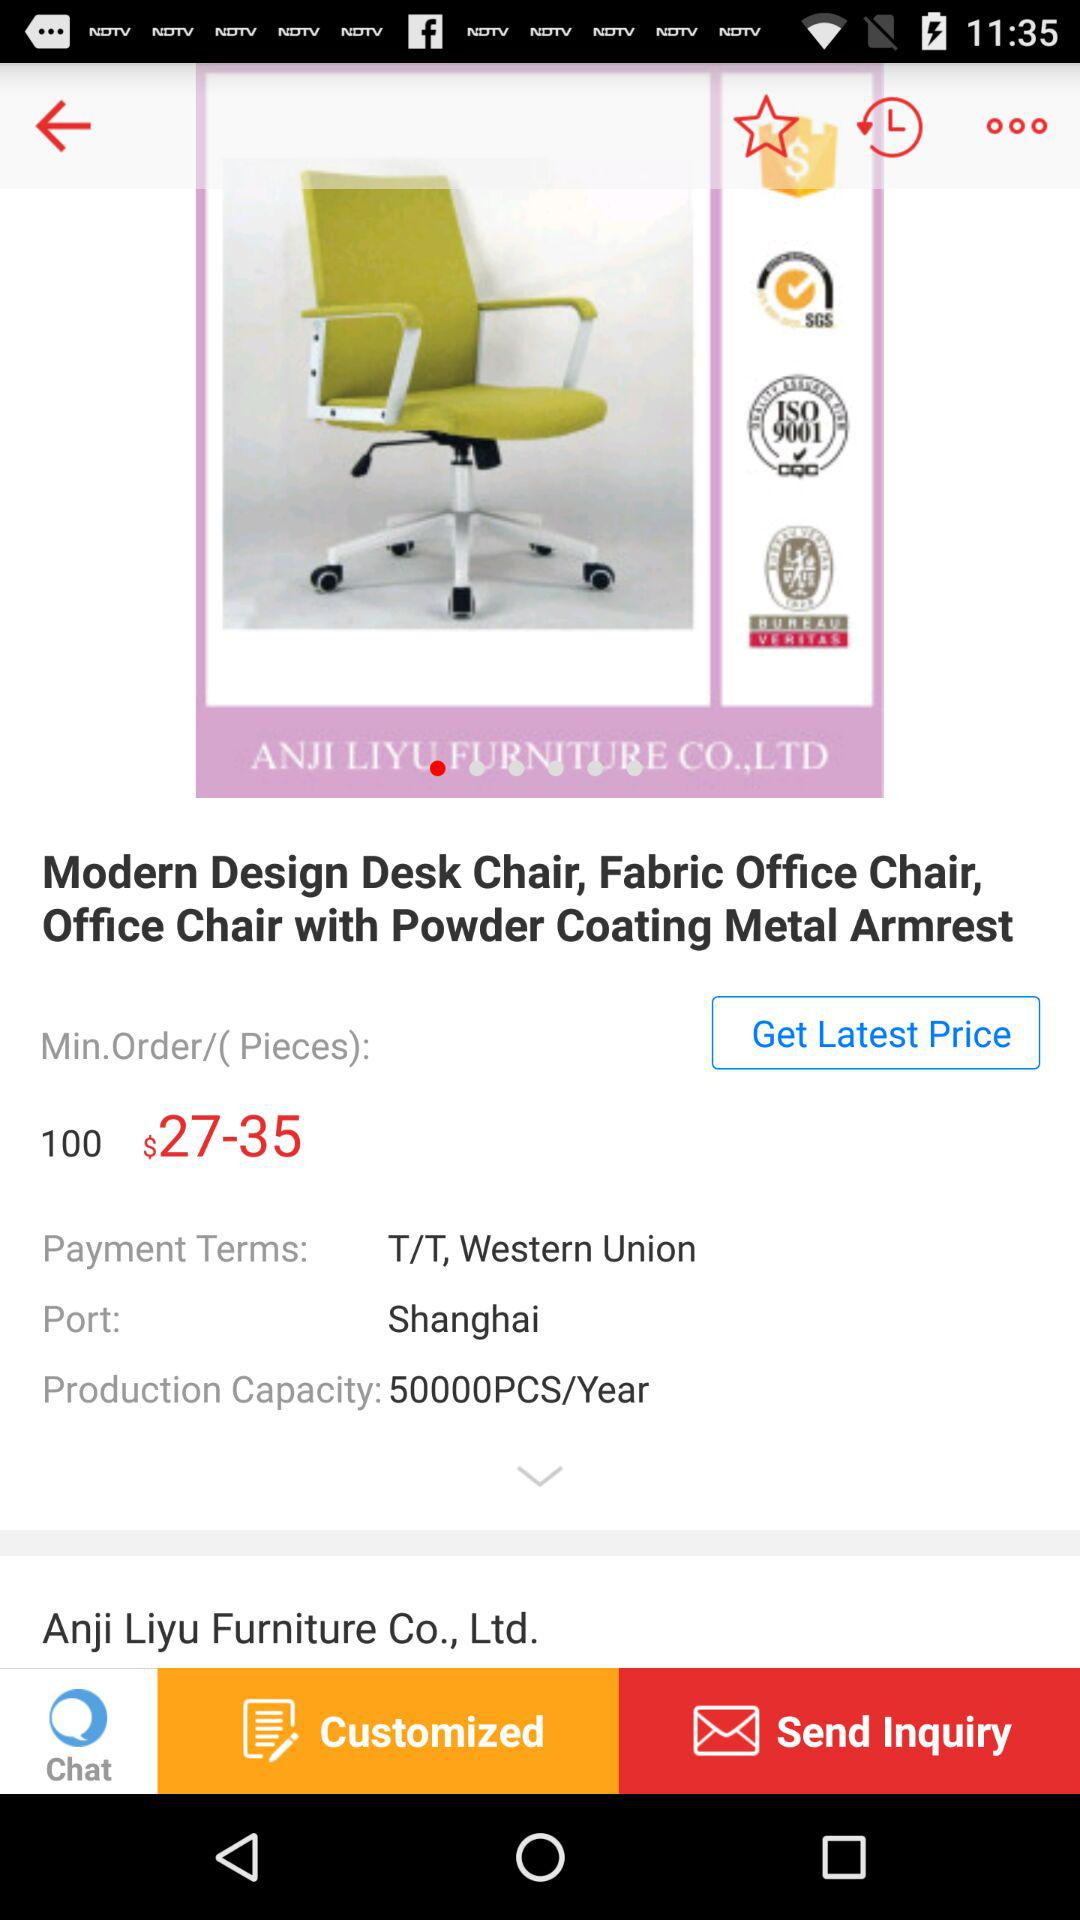What is the payment term?
Answer the question using a single word or phrase. T/T, Western Union 